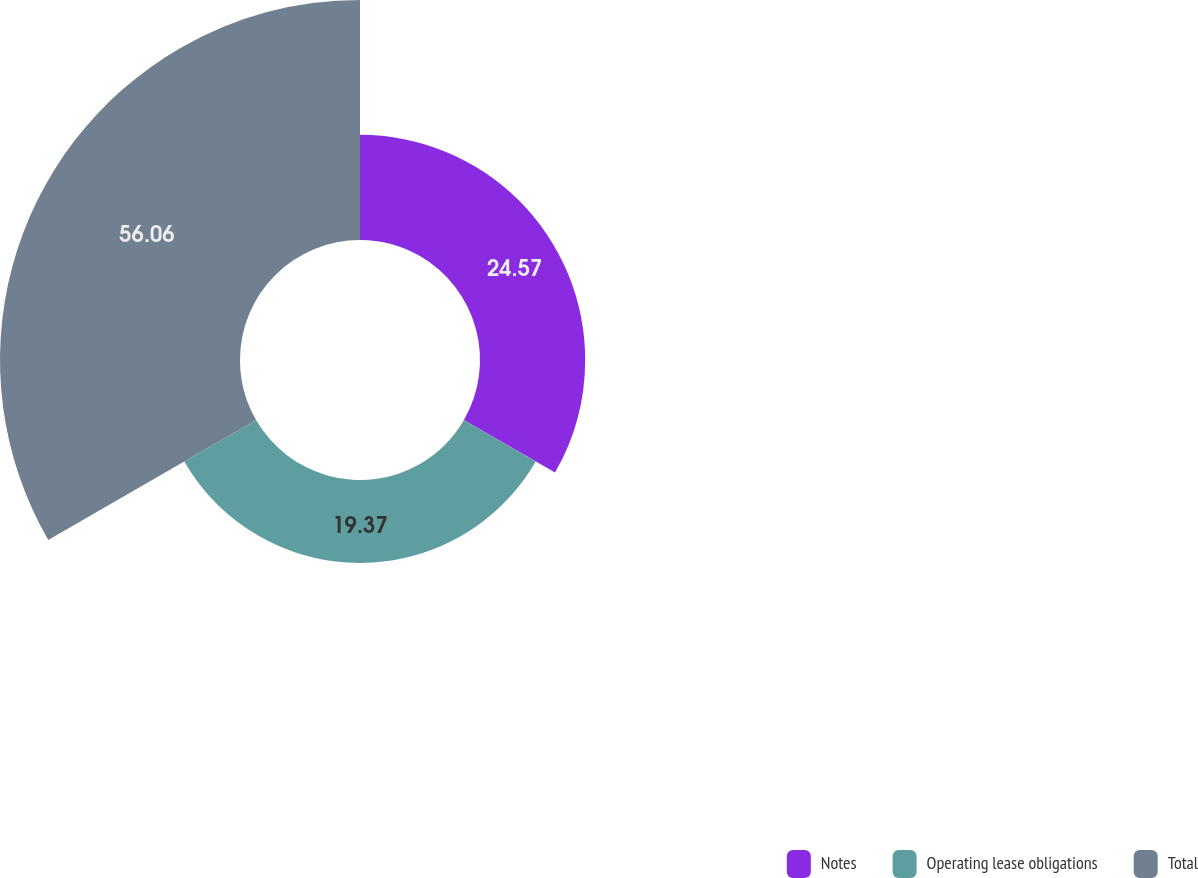<chart> <loc_0><loc_0><loc_500><loc_500><pie_chart><fcel>Notes<fcel>Operating lease obligations<fcel>Total<nl><fcel>24.57%<fcel>19.37%<fcel>56.06%<nl></chart> 